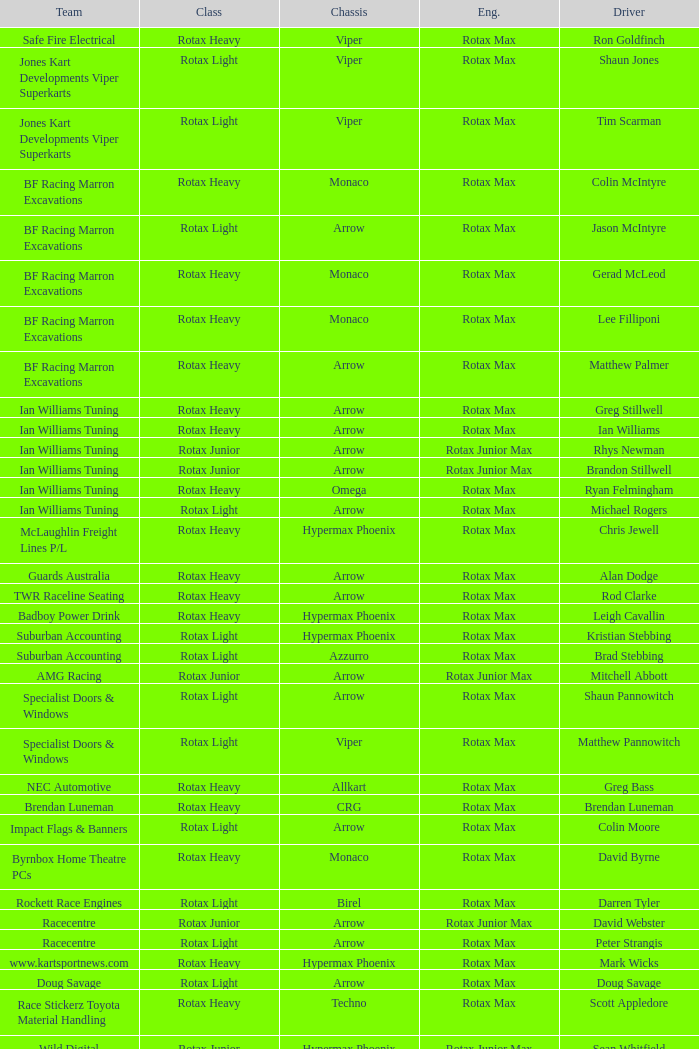What is the name of the driver with a rotax max engine, in the rotax heavy class, with arrow as chassis and on the TWR Raceline Seating team? Rod Clarke. 